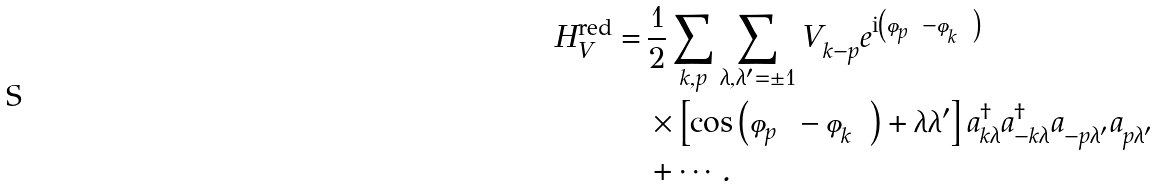<formula> <loc_0><loc_0><loc_500><loc_500>H ^ { \text {red} } _ { V } = & \, \frac { 1 } { 2 } \sum _ { k , p } \sum _ { \lambda , \lambda ^ { \prime } = \pm 1 } V ^ { \ } _ { k - p } e ^ { \text {i} \left ( \varphi ^ { \ } _ { p } - \varphi ^ { \ } _ { k } \right ) } \\ & \, \times \left [ \cos \left ( \varphi ^ { \ } _ { p } - \varphi ^ { \ } _ { k } \right ) + \lambda \lambda ^ { \prime } \right ] a ^ { \dag } _ { k \lambda } a ^ { \dag } _ { - k \lambda } a ^ { \ } _ { - p \lambda ^ { \prime } } a ^ { \ } _ { p \lambda ^ { \prime } } \\ & \, + \cdots .</formula> 